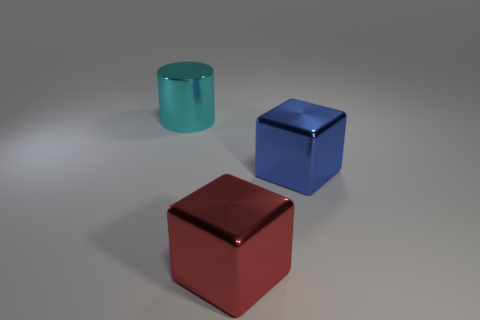Add 2 tiny red metal balls. How many objects exist? 5 Subtract all red blocks. How many blocks are left? 1 Subtract all blocks. How many objects are left? 1 Subtract all yellow cylinders. Subtract all yellow cubes. How many cylinders are left? 1 Subtract all red balls. How many brown cylinders are left? 0 Subtract all big green shiny objects. Subtract all shiny objects. How many objects are left? 0 Add 2 big cyan cylinders. How many big cyan cylinders are left? 3 Add 1 large cyan cylinders. How many large cyan cylinders exist? 2 Subtract 0 gray cylinders. How many objects are left? 3 Subtract 1 cylinders. How many cylinders are left? 0 